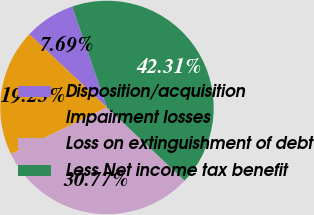Convert chart. <chart><loc_0><loc_0><loc_500><loc_500><pie_chart><fcel>Disposition/acquisition<fcel>Impairment losses<fcel>Loss on extinguishment of debt<fcel>Less Net income tax benefit<nl><fcel>7.69%<fcel>19.23%<fcel>30.77%<fcel>42.31%<nl></chart> 